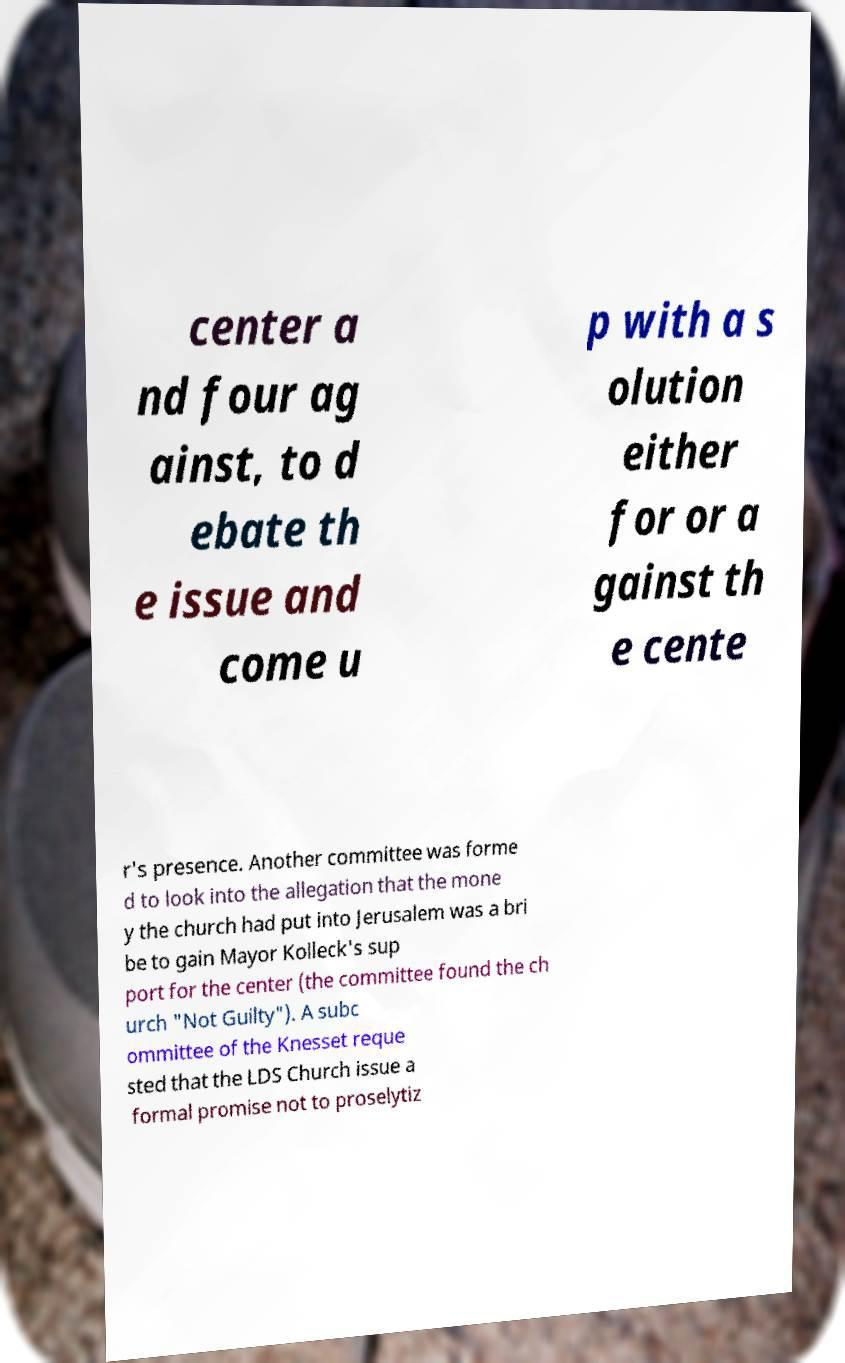There's text embedded in this image that I need extracted. Can you transcribe it verbatim? center a nd four ag ainst, to d ebate th e issue and come u p with a s olution either for or a gainst th e cente r's presence. Another committee was forme d to look into the allegation that the mone y the church had put into Jerusalem was a bri be to gain Mayor Kolleck's sup port for the center (the committee found the ch urch "Not Guilty"). A subc ommittee of the Knesset reque sted that the LDS Church issue a formal promise not to proselytiz 